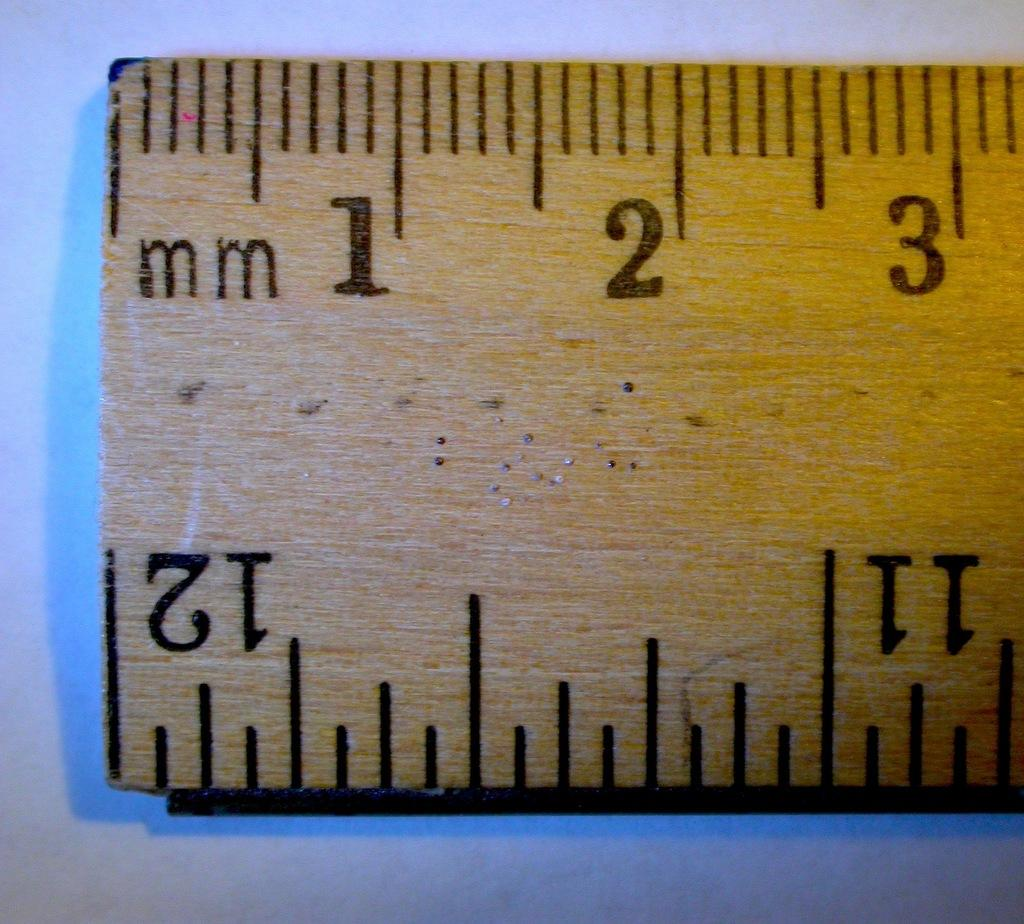<image>
Offer a succinct explanation of the picture presented. A normal wooden rule upclose to show the 1 through 3 mm measurements. 